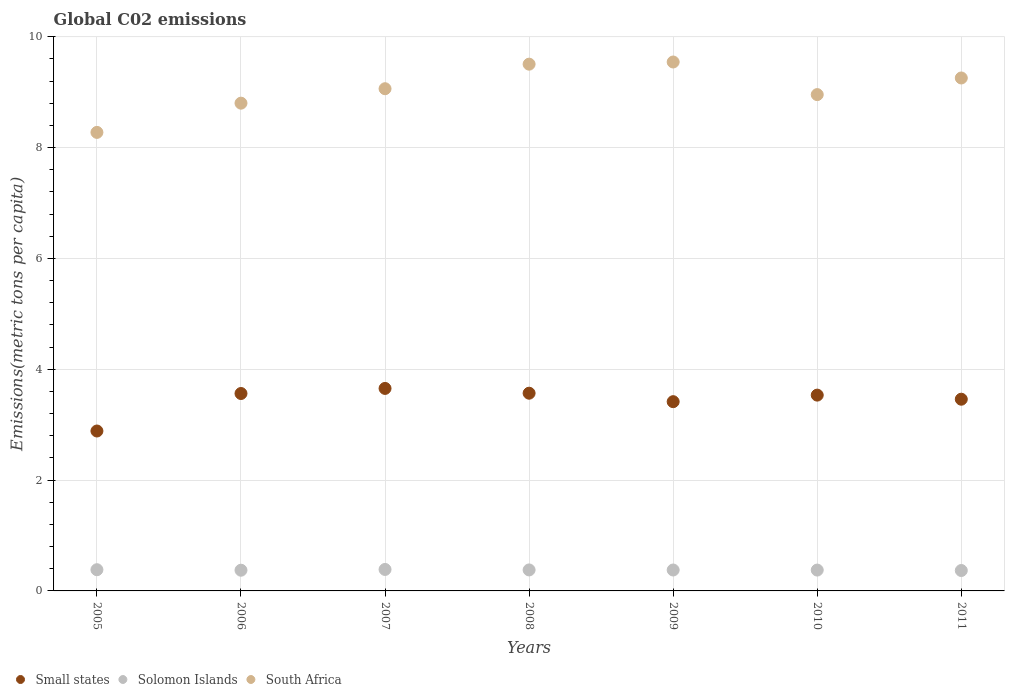Is the number of dotlines equal to the number of legend labels?
Offer a very short reply. Yes. What is the amount of CO2 emitted in in Small states in 2007?
Ensure brevity in your answer.  3.65. Across all years, what is the maximum amount of CO2 emitted in in Solomon Islands?
Make the answer very short. 0.39. Across all years, what is the minimum amount of CO2 emitted in in Small states?
Your answer should be very brief. 2.89. In which year was the amount of CO2 emitted in in Solomon Islands maximum?
Your answer should be very brief. 2007. What is the total amount of CO2 emitted in in Solomon Islands in the graph?
Keep it short and to the point. 2.65. What is the difference between the amount of CO2 emitted in in South Africa in 2006 and that in 2009?
Your answer should be compact. -0.74. What is the difference between the amount of CO2 emitted in in South Africa in 2010 and the amount of CO2 emitted in in Small states in 2009?
Your answer should be compact. 5.54. What is the average amount of CO2 emitted in in South Africa per year?
Your answer should be compact. 9.06. In the year 2007, what is the difference between the amount of CO2 emitted in in Small states and amount of CO2 emitted in in South Africa?
Offer a terse response. -5.41. In how many years, is the amount of CO2 emitted in in Solomon Islands greater than 7.6 metric tons per capita?
Keep it short and to the point. 0. What is the ratio of the amount of CO2 emitted in in Small states in 2007 to that in 2008?
Your answer should be very brief. 1.02. What is the difference between the highest and the second highest amount of CO2 emitted in in Small states?
Your answer should be very brief. 0.09. What is the difference between the highest and the lowest amount of CO2 emitted in in Solomon Islands?
Give a very brief answer. 0.02. In how many years, is the amount of CO2 emitted in in South Africa greater than the average amount of CO2 emitted in in South Africa taken over all years?
Provide a succinct answer. 4. Does the amount of CO2 emitted in in South Africa monotonically increase over the years?
Provide a succinct answer. No. Is the amount of CO2 emitted in in South Africa strictly greater than the amount of CO2 emitted in in Solomon Islands over the years?
Your answer should be compact. Yes. Is the amount of CO2 emitted in in Solomon Islands strictly less than the amount of CO2 emitted in in Small states over the years?
Keep it short and to the point. Yes. How many years are there in the graph?
Offer a very short reply. 7. What is the difference between two consecutive major ticks on the Y-axis?
Ensure brevity in your answer.  2. Are the values on the major ticks of Y-axis written in scientific E-notation?
Make the answer very short. No. How are the legend labels stacked?
Ensure brevity in your answer.  Horizontal. What is the title of the graph?
Offer a very short reply. Global C02 emissions. Does "Kyrgyz Republic" appear as one of the legend labels in the graph?
Offer a very short reply. No. What is the label or title of the X-axis?
Make the answer very short. Years. What is the label or title of the Y-axis?
Give a very brief answer. Emissions(metric tons per capita). What is the Emissions(metric tons per capita) in Small states in 2005?
Offer a terse response. 2.89. What is the Emissions(metric tons per capita) of Solomon Islands in 2005?
Your answer should be compact. 0.38. What is the Emissions(metric tons per capita) of South Africa in 2005?
Provide a succinct answer. 8.28. What is the Emissions(metric tons per capita) of Small states in 2006?
Make the answer very short. 3.56. What is the Emissions(metric tons per capita) in Solomon Islands in 2006?
Your answer should be very brief. 0.37. What is the Emissions(metric tons per capita) of South Africa in 2006?
Your response must be concise. 8.8. What is the Emissions(metric tons per capita) of Small states in 2007?
Make the answer very short. 3.65. What is the Emissions(metric tons per capita) in Solomon Islands in 2007?
Your answer should be very brief. 0.39. What is the Emissions(metric tons per capita) in South Africa in 2007?
Ensure brevity in your answer.  9.06. What is the Emissions(metric tons per capita) of Small states in 2008?
Make the answer very short. 3.57. What is the Emissions(metric tons per capita) of Solomon Islands in 2008?
Make the answer very short. 0.38. What is the Emissions(metric tons per capita) in South Africa in 2008?
Keep it short and to the point. 9.51. What is the Emissions(metric tons per capita) in Small states in 2009?
Offer a very short reply. 3.42. What is the Emissions(metric tons per capita) of Solomon Islands in 2009?
Your answer should be compact. 0.38. What is the Emissions(metric tons per capita) of South Africa in 2009?
Your answer should be compact. 9.55. What is the Emissions(metric tons per capita) of Small states in 2010?
Your answer should be very brief. 3.53. What is the Emissions(metric tons per capita) of Solomon Islands in 2010?
Offer a very short reply. 0.38. What is the Emissions(metric tons per capita) in South Africa in 2010?
Make the answer very short. 8.96. What is the Emissions(metric tons per capita) of Small states in 2011?
Ensure brevity in your answer.  3.46. What is the Emissions(metric tons per capita) of Solomon Islands in 2011?
Give a very brief answer. 0.37. What is the Emissions(metric tons per capita) in South Africa in 2011?
Make the answer very short. 9.26. Across all years, what is the maximum Emissions(metric tons per capita) in Small states?
Give a very brief answer. 3.65. Across all years, what is the maximum Emissions(metric tons per capita) of Solomon Islands?
Offer a terse response. 0.39. Across all years, what is the maximum Emissions(metric tons per capita) in South Africa?
Your answer should be compact. 9.55. Across all years, what is the minimum Emissions(metric tons per capita) in Small states?
Your answer should be compact. 2.89. Across all years, what is the minimum Emissions(metric tons per capita) of Solomon Islands?
Provide a short and direct response. 0.37. Across all years, what is the minimum Emissions(metric tons per capita) in South Africa?
Make the answer very short. 8.28. What is the total Emissions(metric tons per capita) of Small states in the graph?
Make the answer very short. 24.08. What is the total Emissions(metric tons per capita) of Solomon Islands in the graph?
Provide a succinct answer. 2.65. What is the total Emissions(metric tons per capita) of South Africa in the graph?
Provide a succinct answer. 63.41. What is the difference between the Emissions(metric tons per capita) in Small states in 2005 and that in 2006?
Your response must be concise. -0.68. What is the difference between the Emissions(metric tons per capita) in Solomon Islands in 2005 and that in 2006?
Ensure brevity in your answer.  0.01. What is the difference between the Emissions(metric tons per capita) of South Africa in 2005 and that in 2006?
Give a very brief answer. -0.53. What is the difference between the Emissions(metric tons per capita) in Small states in 2005 and that in 2007?
Your answer should be compact. -0.77. What is the difference between the Emissions(metric tons per capita) in Solomon Islands in 2005 and that in 2007?
Give a very brief answer. -0. What is the difference between the Emissions(metric tons per capita) in South Africa in 2005 and that in 2007?
Your answer should be compact. -0.79. What is the difference between the Emissions(metric tons per capita) in Small states in 2005 and that in 2008?
Ensure brevity in your answer.  -0.68. What is the difference between the Emissions(metric tons per capita) of Solomon Islands in 2005 and that in 2008?
Your answer should be compact. 0. What is the difference between the Emissions(metric tons per capita) of South Africa in 2005 and that in 2008?
Ensure brevity in your answer.  -1.23. What is the difference between the Emissions(metric tons per capita) in Small states in 2005 and that in 2009?
Offer a terse response. -0.53. What is the difference between the Emissions(metric tons per capita) in Solomon Islands in 2005 and that in 2009?
Provide a short and direct response. 0.01. What is the difference between the Emissions(metric tons per capita) in South Africa in 2005 and that in 2009?
Offer a very short reply. -1.27. What is the difference between the Emissions(metric tons per capita) in Small states in 2005 and that in 2010?
Your response must be concise. -0.65. What is the difference between the Emissions(metric tons per capita) in Solomon Islands in 2005 and that in 2010?
Offer a terse response. 0.01. What is the difference between the Emissions(metric tons per capita) in South Africa in 2005 and that in 2010?
Offer a very short reply. -0.68. What is the difference between the Emissions(metric tons per capita) in Small states in 2005 and that in 2011?
Provide a short and direct response. -0.57. What is the difference between the Emissions(metric tons per capita) of Solomon Islands in 2005 and that in 2011?
Keep it short and to the point. 0.01. What is the difference between the Emissions(metric tons per capita) of South Africa in 2005 and that in 2011?
Ensure brevity in your answer.  -0.98. What is the difference between the Emissions(metric tons per capita) in Small states in 2006 and that in 2007?
Your answer should be compact. -0.09. What is the difference between the Emissions(metric tons per capita) of Solomon Islands in 2006 and that in 2007?
Make the answer very short. -0.01. What is the difference between the Emissions(metric tons per capita) in South Africa in 2006 and that in 2007?
Keep it short and to the point. -0.26. What is the difference between the Emissions(metric tons per capita) in Small states in 2006 and that in 2008?
Offer a very short reply. -0.01. What is the difference between the Emissions(metric tons per capita) in Solomon Islands in 2006 and that in 2008?
Make the answer very short. -0.01. What is the difference between the Emissions(metric tons per capita) in South Africa in 2006 and that in 2008?
Keep it short and to the point. -0.7. What is the difference between the Emissions(metric tons per capita) of Small states in 2006 and that in 2009?
Give a very brief answer. 0.15. What is the difference between the Emissions(metric tons per capita) in Solomon Islands in 2006 and that in 2009?
Your answer should be compact. -0. What is the difference between the Emissions(metric tons per capita) of South Africa in 2006 and that in 2009?
Offer a very short reply. -0.74. What is the difference between the Emissions(metric tons per capita) of Small states in 2006 and that in 2010?
Your response must be concise. 0.03. What is the difference between the Emissions(metric tons per capita) of Solomon Islands in 2006 and that in 2010?
Make the answer very short. -0. What is the difference between the Emissions(metric tons per capita) in South Africa in 2006 and that in 2010?
Your response must be concise. -0.15. What is the difference between the Emissions(metric tons per capita) in Small states in 2006 and that in 2011?
Offer a very short reply. 0.1. What is the difference between the Emissions(metric tons per capita) in Solomon Islands in 2006 and that in 2011?
Keep it short and to the point. 0.01. What is the difference between the Emissions(metric tons per capita) of South Africa in 2006 and that in 2011?
Offer a very short reply. -0.45. What is the difference between the Emissions(metric tons per capita) in Small states in 2007 and that in 2008?
Keep it short and to the point. 0.09. What is the difference between the Emissions(metric tons per capita) of Solomon Islands in 2007 and that in 2008?
Keep it short and to the point. 0.01. What is the difference between the Emissions(metric tons per capita) of South Africa in 2007 and that in 2008?
Offer a very short reply. -0.44. What is the difference between the Emissions(metric tons per capita) in Small states in 2007 and that in 2009?
Keep it short and to the point. 0.24. What is the difference between the Emissions(metric tons per capita) of Solomon Islands in 2007 and that in 2009?
Offer a very short reply. 0.01. What is the difference between the Emissions(metric tons per capita) in South Africa in 2007 and that in 2009?
Keep it short and to the point. -0.48. What is the difference between the Emissions(metric tons per capita) of Small states in 2007 and that in 2010?
Provide a short and direct response. 0.12. What is the difference between the Emissions(metric tons per capita) in Solomon Islands in 2007 and that in 2010?
Provide a short and direct response. 0.01. What is the difference between the Emissions(metric tons per capita) of South Africa in 2007 and that in 2010?
Ensure brevity in your answer.  0.11. What is the difference between the Emissions(metric tons per capita) in Small states in 2007 and that in 2011?
Provide a succinct answer. 0.19. What is the difference between the Emissions(metric tons per capita) of Solomon Islands in 2007 and that in 2011?
Ensure brevity in your answer.  0.02. What is the difference between the Emissions(metric tons per capita) in South Africa in 2007 and that in 2011?
Give a very brief answer. -0.19. What is the difference between the Emissions(metric tons per capita) in Small states in 2008 and that in 2009?
Offer a terse response. 0.15. What is the difference between the Emissions(metric tons per capita) in Solomon Islands in 2008 and that in 2009?
Make the answer very short. 0. What is the difference between the Emissions(metric tons per capita) of South Africa in 2008 and that in 2009?
Ensure brevity in your answer.  -0.04. What is the difference between the Emissions(metric tons per capita) in Small states in 2008 and that in 2010?
Your answer should be very brief. 0.03. What is the difference between the Emissions(metric tons per capita) of Solomon Islands in 2008 and that in 2010?
Give a very brief answer. 0. What is the difference between the Emissions(metric tons per capita) in South Africa in 2008 and that in 2010?
Provide a short and direct response. 0.55. What is the difference between the Emissions(metric tons per capita) in Small states in 2008 and that in 2011?
Make the answer very short. 0.11. What is the difference between the Emissions(metric tons per capita) of Solomon Islands in 2008 and that in 2011?
Your response must be concise. 0.01. What is the difference between the Emissions(metric tons per capita) of South Africa in 2008 and that in 2011?
Give a very brief answer. 0.25. What is the difference between the Emissions(metric tons per capita) of Small states in 2009 and that in 2010?
Your answer should be very brief. -0.12. What is the difference between the Emissions(metric tons per capita) in Solomon Islands in 2009 and that in 2010?
Provide a short and direct response. 0. What is the difference between the Emissions(metric tons per capita) in South Africa in 2009 and that in 2010?
Offer a terse response. 0.59. What is the difference between the Emissions(metric tons per capita) in Small states in 2009 and that in 2011?
Your answer should be very brief. -0.04. What is the difference between the Emissions(metric tons per capita) in Solomon Islands in 2009 and that in 2011?
Ensure brevity in your answer.  0.01. What is the difference between the Emissions(metric tons per capita) of South Africa in 2009 and that in 2011?
Provide a succinct answer. 0.29. What is the difference between the Emissions(metric tons per capita) in Small states in 2010 and that in 2011?
Give a very brief answer. 0.07. What is the difference between the Emissions(metric tons per capita) in Solomon Islands in 2010 and that in 2011?
Ensure brevity in your answer.  0.01. What is the difference between the Emissions(metric tons per capita) in South Africa in 2010 and that in 2011?
Your answer should be very brief. -0.3. What is the difference between the Emissions(metric tons per capita) of Small states in 2005 and the Emissions(metric tons per capita) of Solomon Islands in 2006?
Offer a very short reply. 2.51. What is the difference between the Emissions(metric tons per capita) in Small states in 2005 and the Emissions(metric tons per capita) in South Africa in 2006?
Offer a terse response. -5.92. What is the difference between the Emissions(metric tons per capita) of Solomon Islands in 2005 and the Emissions(metric tons per capita) of South Africa in 2006?
Provide a succinct answer. -8.42. What is the difference between the Emissions(metric tons per capita) in Small states in 2005 and the Emissions(metric tons per capita) in Solomon Islands in 2007?
Ensure brevity in your answer.  2.5. What is the difference between the Emissions(metric tons per capita) in Small states in 2005 and the Emissions(metric tons per capita) in South Africa in 2007?
Ensure brevity in your answer.  -6.18. What is the difference between the Emissions(metric tons per capita) in Solomon Islands in 2005 and the Emissions(metric tons per capita) in South Africa in 2007?
Ensure brevity in your answer.  -8.68. What is the difference between the Emissions(metric tons per capita) of Small states in 2005 and the Emissions(metric tons per capita) of Solomon Islands in 2008?
Keep it short and to the point. 2.51. What is the difference between the Emissions(metric tons per capita) of Small states in 2005 and the Emissions(metric tons per capita) of South Africa in 2008?
Provide a short and direct response. -6.62. What is the difference between the Emissions(metric tons per capita) in Solomon Islands in 2005 and the Emissions(metric tons per capita) in South Africa in 2008?
Your answer should be very brief. -9.12. What is the difference between the Emissions(metric tons per capita) of Small states in 2005 and the Emissions(metric tons per capita) of Solomon Islands in 2009?
Provide a succinct answer. 2.51. What is the difference between the Emissions(metric tons per capita) of Small states in 2005 and the Emissions(metric tons per capita) of South Africa in 2009?
Give a very brief answer. -6.66. What is the difference between the Emissions(metric tons per capita) of Solomon Islands in 2005 and the Emissions(metric tons per capita) of South Africa in 2009?
Keep it short and to the point. -9.16. What is the difference between the Emissions(metric tons per capita) of Small states in 2005 and the Emissions(metric tons per capita) of Solomon Islands in 2010?
Make the answer very short. 2.51. What is the difference between the Emissions(metric tons per capita) in Small states in 2005 and the Emissions(metric tons per capita) in South Africa in 2010?
Ensure brevity in your answer.  -6.07. What is the difference between the Emissions(metric tons per capita) of Solomon Islands in 2005 and the Emissions(metric tons per capita) of South Africa in 2010?
Keep it short and to the point. -8.57. What is the difference between the Emissions(metric tons per capita) of Small states in 2005 and the Emissions(metric tons per capita) of Solomon Islands in 2011?
Offer a terse response. 2.52. What is the difference between the Emissions(metric tons per capita) of Small states in 2005 and the Emissions(metric tons per capita) of South Africa in 2011?
Provide a short and direct response. -6.37. What is the difference between the Emissions(metric tons per capita) in Solomon Islands in 2005 and the Emissions(metric tons per capita) in South Africa in 2011?
Keep it short and to the point. -8.87. What is the difference between the Emissions(metric tons per capita) of Small states in 2006 and the Emissions(metric tons per capita) of Solomon Islands in 2007?
Make the answer very short. 3.18. What is the difference between the Emissions(metric tons per capita) in Small states in 2006 and the Emissions(metric tons per capita) in South Africa in 2007?
Offer a very short reply. -5.5. What is the difference between the Emissions(metric tons per capita) of Solomon Islands in 2006 and the Emissions(metric tons per capita) of South Africa in 2007?
Your answer should be compact. -8.69. What is the difference between the Emissions(metric tons per capita) in Small states in 2006 and the Emissions(metric tons per capita) in Solomon Islands in 2008?
Your answer should be very brief. 3.18. What is the difference between the Emissions(metric tons per capita) in Small states in 2006 and the Emissions(metric tons per capita) in South Africa in 2008?
Give a very brief answer. -5.94. What is the difference between the Emissions(metric tons per capita) of Solomon Islands in 2006 and the Emissions(metric tons per capita) of South Africa in 2008?
Offer a terse response. -9.13. What is the difference between the Emissions(metric tons per capita) of Small states in 2006 and the Emissions(metric tons per capita) of Solomon Islands in 2009?
Give a very brief answer. 3.19. What is the difference between the Emissions(metric tons per capita) of Small states in 2006 and the Emissions(metric tons per capita) of South Africa in 2009?
Keep it short and to the point. -5.98. What is the difference between the Emissions(metric tons per capita) of Solomon Islands in 2006 and the Emissions(metric tons per capita) of South Africa in 2009?
Make the answer very short. -9.17. What is the difference between the Emissions(metric tons per capita) of Small states in 2006 and the Emissions(metric tons per capita) of Solomon Islands in 2010?
Ensure brevity in your answer.  3.19. What is the difference between the Emissions(metric tons per capita) in Small states in 2006 and the Emissions(metric tons per capita) in South Africa in 2010?
Your answer should be compact. -5.39. What is the difference between the Emissions(metric tons per capita) of Solomon Islands in 2006 and the Emissions(metric tons per capita) of South Africa in 2010?
Give a very brief answer. -8.58. What is the difference between the Emissions(metric tons per capita) in Small states in 2006 and the Emissions(metric tons per capita) in Solomon Islands in 2011?
Your answer should be compact. 3.19. What is the difference between the Emissions(metric tons per capita) in Small states in 2006 and the Emissions(metric tons per capita) in South Africa in 2011?
Offer a very short reply. -5.69. What is the difference between the Emissions(metric tons per capita) of Solomon Islands in 2006 and the Emissions(metric tons per capita) of South Africa in 2011?
Your answer should be very brief. -8.88. What is the difference between the Emissions(metric tons per capita) of Small states in 2007 and the Emissions(metric tons per capita) of Solomon Islands in 2008?
Keep it short and to the point. 3.28. What is the difference between the Emissions(metric tons per capita) of Small states in 2007 and the Emissions(metric tons per capita) of South Africa in 2008?
Your answer should be compact. -5.85. What is the difference between the Emissions(metric tons per capita) of Solomon Islands in 2007 and the Emissions(metric tons per capita) of South Africa in 2008?
Give a very brief answer. -9.12. What is the difference between the Emissions(metric tons per capita) of Small states in 2007 and the Emissions(metric tons per capita) of Solomon Islands in 2009?
Your answer should be very brief. 3.28. What is the difference between the Emissions(metric tons per capita) in Small states in 2007 and the Emissions(metric tons per capita) in South Africa in 2009?
Give a very brief answer. -5.89. What is the difference between the Emissions(metric tons per capita) in Solomon Islands in 2007 and the Emissions(metric tons per capita) in South Africa in 2009?
Offer a terse response. -9.16. What is the difference between the Emissions(metric tons per capita) in Small states in 2007 and the Emissions(metric tons per capita) in Solomon Islands in 2010?
Offer a very short reply. 3.28. What is the difference between the Emissions(metric tons per capita) of Small states in 2007 and the Emissions(metric tons per capita) of South Africa in 2010?
Provide a succinct answer. -5.3. What is the difference between the Emissions(metric tons per capita) in Solomon Islands in 2007 and the Emissions(metric tons per capita) in South Africa in 2010?
Give a very brief answer. -8.57. What is the difference between the Emissions(metric tons per capita) in Small states in 2007 and the Emissions(metric tons per capita) in Solomon Islands in 2011?
Offer a very short reply. 3.29. What is the difference between the Emissions(metric tons per capita) in Small states in 2007 and the Emissions(metric tons per capita) in South Africa in 2011?
Keep it short and to the point. -5.6. What is the difference between the Emissions(metric tons per capita) in Solomon Islands in 2007 and the Emissions(metric tons per capita) in South Africa in 2011?
Your response must be concise. -8.87. What is the difference between the Emissions(metric tons per capita) in Small states in 2008 and the Emissions(metric tons per capita) in Solomon Islands in 2009?
Offer a terse response. 3.19. What is the difference between the Emissions(metric tons per capita) in Small states in 2008 and the Emissions(metric tons per capita) in South Africa in 2009?
Provide a succinct answer. -5.98. What is the difference between the Emissions(metric tons per capita) of Solomon Islands in 2008 and the Emissions(metric tons per capita) of South Africa in 2009?
Your answer should be compact. -9.17. What is the difference between the Emissions(metric tons per capita) in Small states in 2008 and the Emissions(metric tons per capita) in Solomon Islands in 2010?
Your answer should be very brief. 3.19. What is the difference between the Emissions(metric tons per capita) in Small states in 2008 and the Emissions(metric tons per capita) in South Africa in 2010?
Give a very brief answer. -5.39. What is the difference between the Emissions(metric tons per capita) in Solomon Islands in 2008 and the Emissions(metric tons per capita) in South Africa in 2010?
Make the answer very short. -8.58. What is the difference between the Emissions(metric tons per capita) in Small states in 2008 and the Emissions(metric tons per capita) in Solomon Islands in 2011?
Provide a succinct answer. 3.2. What is the difference between the Emissions(metric tons per capita) in Small states in 2008 and the Emissions(metric tons per capita) in South Africa in 2011?
Keep it short and to the point. -5.69. What is the difference between the Emissions(metric tons per capita) of Solomon Islands in 2008 and the Emissions(metric tons per capita) of South Africa in 2011?
Ensure brevity in your answer.  -8.88. What is the difference between the Emissions(metric tons per capita) of Small states in 2009 and the Emissions(metric tons per capita) of Solomon Islands in 2010?
Your answer should be very brief. 3.04. What is the difference between the Emissions(metric tons per capita) in Small states in 2009 and the Emissions(metric tons per capita) in South Africa in 2010?
Ensure brevity in your answer.  -5.54. What is the difference between the Emissions(metric tons per capita) of Solomon Islands in 2009 and the Emissions(metric tons per capita) of South Africa in 2010?
Keep it short and to the point. -8.58. What is the difference between the Emissions(metric tons per capita) in Small states in 2009 and the Emissions(metric tons per capita) in Solomon Islands in 2011?
Provide a short and direct response. 3.05. What is the difference between the Emissions(metric tons per capita) of Small states in 2009 and the Emissions(metric tons per capita) of South Africa in 2011?
Your answer should be very brief. -5.84. What is the difference between the Emissions(metric tons per capita) of Solomon Islands in 2009 and the Emissions(metric tons per capita) of South Africa in 2011?
Give a very brief answer. -8.88. What is the difference between the Emissions(metric tons per capita) in Small states in 2010 and the Emissions(metric tons per capita) in Solomon Islands in 2011?
Keep it short and to the point. 3.17. What is the difference between the Emissions(metric tons per capita) in Small states in 2010 and the Emissions(metric tons per capita) in South Africa in 2011?
Provide a short and direct response. -5.72. What is the difference between the Emissions(metric tons per capita) of Solomon Islands in 2010 and the Emissions(metric tons per capita) of South Africa in 2011?
Provide a succinct answer. -8.88. What is the average Emissions(metric tons per capita) in Small states per year?
Your response must be concise. 3.44. What is the average Emissions(metric tons per capita) in Solomon Islands per year?
Your response must be concise. 0.38. What is the average Emissions(metric tons per capita) of South Africa per year?
Keep it short and to the point. 9.06. In the year 2005, what is the difference between the Emissions(metric tons per capita) in Small states and Emissions(metric tons per capita) in Solomon Islands?
Provide a succinct answer. 2.5. In the year 2005, what is the difference between the Emissions(metric tons per capita) in Small states and Emissions(metric tons per capita) in South Africa?
Your response must be concise. -5.39. In the year 2005, what is the difference between the Emissions(metric tons per capita) in Solomon Islands and Emissions(metric tons per capita) in South Africa?
Offer a very short reply. -7.89. In the year 2006, what is the difference between the Emissions(metric tons per capita) in Small states and Emissions(metric tons per capita) in Solomon Islands?
Offer a very short reply. 3.19. In the year 2006, what is the difference between the Emissions(metric tons per capita) in Small states and Emissions(metric tons per capita) in South Africa?
Provide a succinct answer. -5.24. In the year 2006, what is the difference between the Emissions(metric tons per capita) in Solomon Islands and Emissions(metric tons per capita) in South Africa?
Provide a short and direct response. -8.43. In the year 2007, what is the difference between the Emissions(metric tons per capita) of Small states and Emissions(metric tons per capita) of Solomon Islands?
Provide a succinct answer. 3.27. In the year 2007, what is the difference between the Emissions(metric tons per capita) of Small states and Emissions(metric tons per capita) of South Africa?
Your answer should be very brief. -5.41. In the year 2007, what is the difference between the Emissions(metric tons per capita) of Solomon Islands and Emissions(metric tons per capita) of South Africa?
Provide a succinct answer. -8.68. In the year 2008, what is the difference between the Emissions(metric tons per capita) of Small states and Emissions(metric tons per capita) of Solomon Islands?
Ensure brevity in your answer.  3.19. In the year 2008, what is the difference between the Emissions(metric tons per capita) in Small states and Emissions(metric tons per capita) in South Africa?
Provide a short and direct response. -5.94. In the year 2008, what is the difference between the Emissions(metric tons per capita) of Solomon Islands and Emissions(metric tons per capita) of South Africa?
Your response must be concise. -9.13. In the year 2009, what is the difference between the Emissions(metric tons per capita) of Small states and Emissions(metric tons per capita) of Solomon Islands?
Provide a short and direct response. 3.04. In the year 2009, what is the difference between the Emissions(metric tons per capita) of Small states and Emissions(metric tons per capita) of South Africa?
Provide a succinct answer. -6.13. In the year 2009, what is the difference between the Emissions(metric tons per capita) in Solomon Islands and Emissions(metric tons per capita) in South Africa?
Make the answer very short. -9.17. In the year 2010, what is the difference between the Emissions(metric tons per capita) of Small states and Emissions(metric tons per capita) of Solomon Islands?
Provide a succinct answer. 3.16. In the year 2010, what is the difference between the Emissions(metric tons per capita) of Small states and Emissions(metric tons per capita) of South Africa?
Make the answer very short. -5.42. In the year 2010, what is the difference between the Emissions(metric tons per capita) of Solomon Islands and Emissions(metric tons per capita) of South Africa?
Offer a very short reply. -8.58. In the year 2011, what is the difference between the Emissions(metric tons per capita) in Small states and Emissions(metric tons per capita) in Solomon Islands?
Offer a very short reply. 3.09. In the year 2011, what is the difference between the Emissions(metric tons per capita) in Small states and Emissions(metric tons per capita) in South Africa?
Make the answer very short. -5.8. In the year 2011, what is the difference between the Emissions(metric tons per capita) of Solomon Islands and Emissions(metric tons per capita) of South Africa?
Offer a very short reply. -8.89. What is the ratio of the Emissions(metric tons per capita) of Small states in 2005 to that in 2006?
Ensure brevity in your answer.  0.81. What is the ratio of the Emissions(metric tons per capita) in Solomon Islands in 2005 to that in 2006?
Offer a very short reply. 1.02. What is the ratio of the Emissions(metric tons per capita) of South Africa in 2005 to that in 2006?
Provide a short and direct response. 0.94. What is the ratio of the Emissions(metric tons per capita) of Small states in 2005 to that in 2007?
Give a very brief answer. 0.79. What is the ratio of the Emissions(metric tons per capita) in South Africa in 2005 to that in 2007?
Your answer should be very brief. 0.91. What is the ratio of the Emissions(metric tons per capita) of Small states in 2005 to that in 2008?
Provide a short and direct response. 0.81. What is the ratio of the Emissions(metric tons per capita) of Solomon Islands in 2005 to that in 2008?
Offer a terse response. 1.01. What is the ratio of the Emissions(metric tons per capita) of South Africa in 2005 to that in 2008?
Offer a terse response. 0.87. What is the ratio of the Emissions(metric tons per capita) of Small states in 2005 to that in 2009?
Your answer should be very brief. 0.84. What is the ratio of the Emissions(metric tons per capita) in Solomon Islands in 2005 to that in 2009?
Give a very brief answer. 1.01. What is the ratio of the Emissions(metric tons per capita) in South Africa in 2005 to that in 2009?
Give a very brief answer. 0.87. What is the ratio of the Emissions(metric tons per capita) of Small states in 2005 to that in 2010?
Your answer should be very brief. 0.82. What is the ratio of the Emissions(metric tons per capita) in Solomon Islands in 2005 to that in 2010?
Your answer should be very brief. 1.02. What is the ratio of the Emissions(metric tons per capita) in South Africa in 2005 to that in 2010?
Provide a succinct answer. 0.92. What is the ratio of the Emissions(metric tons per capita) in Small states in 2005 to that in 2011?
Make the answer very short. 0.83. What is the ratio of the Emissions(metric tons per capita) in Solomon Islands in 2005 to that in 2011?
Ensure brevity in your answer.  1.04. What is the ratio of the Emissions(metric tons per capita) in South Africa in 2005 to that in 2011?
Ensure brevity in your answer.  0.89. What is the ratio of the Emissions(metric tons per capita) in Small states in 2006 to that in 2007?
Give a very brief answer. 0.97. What is the ratio of the Emissions(metric tons per capita) in Solomon Islands in 2006 to that in 2007?
Offer a terse response. 0.96. What is the ratio of the Emissions(metric tons per capita) of South Africa in 2006 to that in 2007?
Your response must be concise. 0.97. What is the ratio of the Emissions(metric tons per capita) in South Africa in 2006 to that in 2008?
Give a very brief answer. 0.93. What is the ratio of the Emissions(metric tons per capita) in Small states in 2006 to that in 2009?
Keep it short and to the point. 1.04. What is the ratio of the Emissions(metric tons per capita) in South Africa in 2006 to that in 2009?
Your answer should be compact. 0.92. What is the ratio of the Emissions(metric tons per capita) in Small states in 2006 to that in 2010?
Make the answer very short. 1.01. What is the ratio of the Emissions(metric tons per capita) in Solomon Islands in 2006 to that in 2010?
Provide a succinct answer. 0.99. What is the ratio of the Emissions(metric tons per capita) of South Africa in 2006 to that in 2010?
Ensure brevity in your answer.  0.98. What is the ratio of the Emissions(metric tons per capita) in Small states in 2006 to that in 2011?
Keep it short and to the point. 1.03. What is the ratio of the Emissions(metric tons per capita) in Solomon Islands in 2006 to that in 2011?
Your answer should be very brief. 1.01. What is the ratio of the Emissions(metric tons per capita) in South Africa in 2006 to that in 2011?
Provide a succinct answer. 0.95. What is the ratio of the Emissions(metric tons per capita) in Small states in 2007 to that in 2008?
Make the answer very short. 1.02. What is the ratio of the Emissions(metric tons per capita) of Solomon Islands in 2007 to that in 2008?
Provide a succinct answer. 1.02. What is the ratio of the Emissions(metric tons per capita) in South Africa in 2007 to that in 2008?
Your answer should be very brief. 0.95. What is the ratio of the Emissions(metric tons per capita) of Small states in 2007 to that in 2009?
Your answer should be compact. 1.07. What is the ratio of the Emissions(metric tons per capita) in Solomon Islands in 2007 to that in 2009?
Your answer should be compact. 1.03. What is the ratio of the Emissions(metric tons per capita) in South Africa in 2007 to that in 2009?
Make the answer very short. 0.95. What is the ratio of the Emissions(metric tons per capita) of Small states in 2007 to that in 2010?
Offer a terse response. 1.03. What is the ratio of the Emissions(metric tons per capita) in Solomon Islands in 2007 to that in 2010?
Keep it short and to the point. 1.03. What is the ratio of the Emissions(metric tons per capita) in South Africa in 2007 to that in 2010?
Offer a very short reply. 1.01. What is the ratio of the Emissions(metric tons per capita) of Small states in 2007 to that in 2011?
Provide a succinct answer. 1.06. What is the ratio of the Emissions(metric tons per capita) in Solomon Islands in 2007 to that in 2011?
Make the answer very short. 1.05. What is the ratio of the Emissions(metric tons per capita) in South Africa in 2007 to that in 2011?
Your answer should be compact. 0.98. What is the ratio of the Emissions(metric tons per capita) of Small states in 2008 to that in 2009?
Give a very brief answer. 1.04. What is the ratio of the Emissions(metric tons per capita) in Small states in 2008 to that in 2010?
Ensure brevity in your answer.  1.01. What is the ratio of the Emissions(metric tons per capita) of South Africa in 2008 to that in 2010?
Give a very brief answer. 1.06. What is the ratio of the Emissions(metric tons per capita) in Small states in 2008 to that in 2011?
Give a very brief answer. 1.03. What is the ratio of the Emissions(metric tons per capita) in Solomon Islands in 2008 to that in 2011?
Your answer should be very brief. 1.03. What is the ratio of the Emissions(metric tons per capita) in South Africa in 2008 to that in 2011?
Your answer should be compact. 1.03. What is the ratio of the Emissions(metric tons per capita) of Small states in 2009 to that in 2010?
Your response must be concise. 0.97. What is the ratio of the Emissions(metric tons per capita) of Solomon Islands in 2009 to that in 2010?
Keep it short and to the point. 1. What is the ratio of the Emissions(metric tons per capita) in South Africa in 2009 to that in 2010?
Ensure brevity in your answer.  1.07. What is the ratio of the Emissions(metric tons per capita) of Small states in 2009 to that in 2011?
Your answer should be very brief. 0.99. What is the ratio of the Emissions(metric tons per capita) in Solomon Islands in 2009 to that in 2011?
Give a very brief answer. 1.03. What is the ratio of the Emissions(metric tons per capita) in South Africa in 2009 to that in 2011?
Offer a terse response. 1.03. What is the ratio of the Emissions(metric tons per capita) in Small states in 2010 to that in 2011?
Provide a succinct answer. 1.02. What is the ratio of the Emissions(metric tons per capita) of Solomon Islands in 2010 to that in 2011?
Give a very brief answer. 1.02. What is the ratio of the Emissions(metric tons per capita) in South Africa in 2010 to that in 2011?
Your response must be concise. 0.97. What is the difference between the highest and the second highest Emissions(metric tons per capita) of Small states?
Ensure brevity in your answer.  0.09. What is the difference between the highest and the second highest Emissions(metric tons per capita) of Solomon Islands?
Your answer should be compact. 0. What is the difference between the highest and the second highest Emissions(metric tons per capita) in South Africa?
Your answer should be compact. 0.04. What is the difference between the highest and the lowest Emissions(metric tons per capita) in Small states?
Make the answer very short. 0.77. What is the difference between the highest and the lowest Emissions(metric tons per capita) of Solomon Islands?
Provide a succinct answer. 0.02. What is the difference between the highest and the lowest Emissions(metric tons per capita) of South Africa?
Your response must be concise. 1.27. 